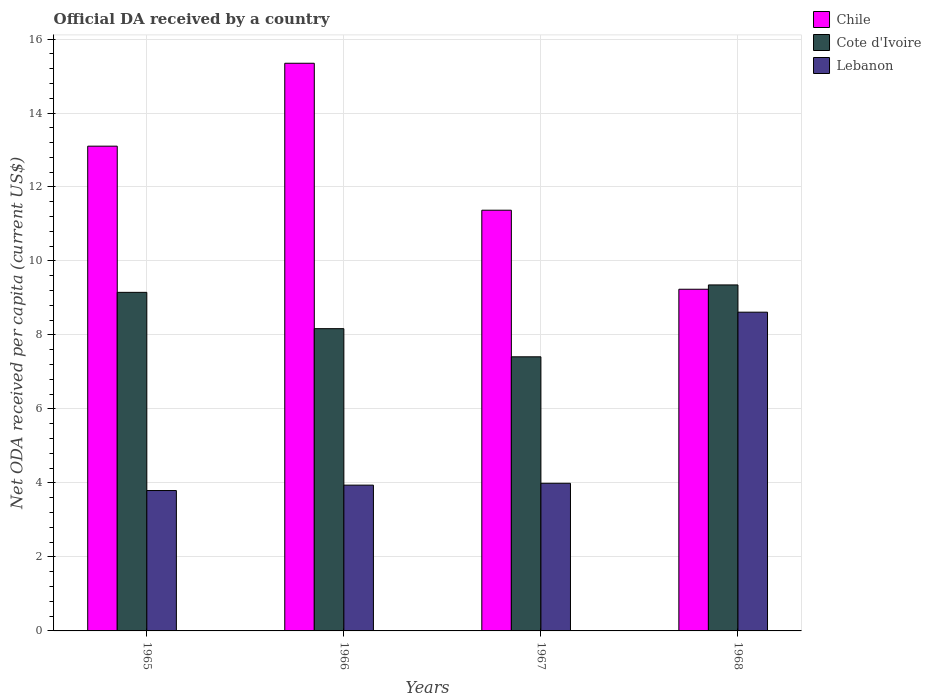How many groups of bars are there?
Your response must be concise. 4. Are the number of bars per tick equal to the number of legend labels?
Your answer should be compact. Yes. What is the label of the 4th group of bars from the left?
Keep it short and to the point. 1968. What is the ODA received in in Chile in 1965?
Ensure brevity in your answer.  13.1. Across all years, what is the maximum ODA received in in Chile?
Your answer should be very brief. 15.34. Across all years, what is the minimum ODA received in in Chile?
Make the answer very short. 9.24. In which year was the ODA received in in Chile maximum?
Your answer should be compact. 1966. In which year was the ODA received in in Lebanon minimum?
Provide a succinct answer. 1965. What is the total ODA received in in Cote d'Ivoire in the graph?
Provide a short and direct response. 34.08. What is the difference between the ODA received in in Chile in 1966 and that in 1967?
Provide a short and direct response. 3.97. What is the difference between the ODA received in in Lebanon in 1966 and the ODA received in in Cote d'Ivoire in 1967?
Your answer should be very brief. -3.47. What is the average ODA received in in Lebanon per year?
Your response must be concise. 5.09. In the year 1968, what is the difference between the ODA received in in Cote d'Ivoire and ODA received in in Chile?
Your response must be concise. 0.12. What is the ratio of the ODA received in in Lebanon in 1965 to that in 1968?
Provide a short and direct response. 0.44. Is the ODA received in in Lebanon in 1965 less than that in 1968?
Your response must be concise. Yes. What is the difference between the highest and the second highest ODA received in in Chile?
Your answer should be compact. 2.24. What is the difference between the highest and the lowest ODA received in in Lebanon?
Make the answer very short. 4.82. Is the sum of the ODA received in in Chile in 1966 and 1967 greater than the maximum ODA received in in Cote d'Ivoire across all years?
Give a very brief answer. Yes. What does the 3rd bar from the left in 1968 represents?
Your answer should be compact. Lebanon. Is it the case that in every year, the sum of the ODA received in in Cote d'Ivoire and ODA received in in Chile is greater than the ODA received in in Lebanon?
Make the answer very short. Yes. How many bars are there?
Your answer should be very brief. 12. Are all the bars in the graph horizontal?
Your response must be concise. No. What is the difference between two consecutive major ticks on the Y-axis?
Your answer should be compact. 2. Does the graph contain any zero values?
Provide a succinct answer. No. How are the legend labels stacked?
Ensure brevity in your answer.  Vertical. What is the title of the graph?
Your answer should be very brief. Official DA received by a country. Does "Philippines" appear as one of the legend labels in the graph?
Your answer should be compact. No. What is the label or title of the X-axis?
Your response must be concise. Years. What is the label or title of the Y-axis?
Offer a terse response. Net ODA received per capita (current US$). What is the Net ODA received per capita (current US$) in Chile in 1965?
Offer a very short reply. 13.1. What is the Net ODA received per capita (current US$) in Cote d'Ivoire in 1965?
Your answer should be compact. 9.15. What is the Net ODA received per capita (current US$) in Lebanon in 1965?
Your answer should be compact. 3.79. What is the Net ODA received per capita (current US$) of Chile in 1966?
Keep it short and to the point. 15.34. What is the Net ODA received per capita (current US$) in Cote d'Ivoire in 1966?
Your answer should be very brief. 8.17. What is the Net ODA received per capita (current US$) in Lebanon in 1966?
Make the answer very short. 3.94. What is the Net ODA received per capita (current US$) in Chile in 1967?
Provide a short and direct response. 11.37. What is the Net ODA received per capita (current US$) of Cote d'Ivoire in 1967?
Your response must be concise. 7.41. What is the Net ODA received per capita (current US$) of Lebanon in 1967?
Offer a very short reply. 3.99. What is the Net ODA received per capita (current US$) of Chile in 1968?
Your response must be concise. 9.24. What is the Net ODA received per capita (current US$) of Cote d'Ivoire in 1968?
Provide a short and direct response. 9.35. What is the Net ODA received per capita (current US$) in Lebanon in 1968?
Your answer should be very brief. 8.62. Across all years, what is the maximum Net ODA received per capita (current US$) of Chile?
Ensure brevity in your answer.  15.34. Across all years, what is the maximum Net ODA received per capita (current US$) in Cote d'Ivoire?
Your response must be concise. 9.35. Across all years, what is the maximum Net ODA received per capita (current US$) of Lebanon?
Your answer should be very brief. 8.62. Across all years, what is the minimum Net ODA received per capita (current US$) in Chile?
Provide a short and direct response. 9.24. Across all years, what is the minimum Net ODA received per capita (current US$) in Cote d'Ivoire?
Keep it short and to the point. 7.41. Across all years, what is the minimum Net ODA received per capita (current US$) in Lebanon?
Provide a short and direct response. 3.79. What is the total Net ODA received per capita (current US$) of Chile in the graph?
Make the answer very short. 49.06. What is the total Net ODA received per capita (current US$) in Cote d'Ivoire in the graph?
Keep it short and to the point. 34.08. What is the total Net ODA received per capita (current US$) in Lebanon in the graph?
Provide a short and direct response. 20.34. What is the difference between the Net ODA received per capita (current US$) in Chile in 1965 and that in 1966?
Offer a terse response. -2.24. What is the difference between the Net ODA received per capita (current US$) of Cote d'Ivoire in 1965 and that in 1966?
Offer a terse response. 0.98. What is the difference between the Net ODA received per capita (current US$) in Lebanon in 1965 and that in 1966?
Give a very brief answer. -0.15. What is the difference between the Net ODA received per capita (current US$) of Chile in 1965 and that in 1967?
Make the answer very short. 1.73. What is the difference between the Net ODA received per capita (current US$) of Cote d'Ivoire in 1965 and that in 1967?
Provide a short and direct response. 1.74. What is the difference between the Net ODA received per capita (current US$) in Lebanon in 1965 and that in 1967?
Make the answer very short. -0.2. What is the difference between the Net ODA received per capita (current US$) of Chile in 1965 and that in 1968?
Keep it short and to the point. 3.87. What is the difference between the Net ODA received per capita (current US$) in Cote d'Ivoire in 1965 and that in 1968?
Offer a very short reply. -0.2. What is the difference between the Net ODA received per capita (current US$) of Lebanon in 1965 and that in 1968?
Offer a very short reply. -4.82. What is the difference between the Net ODA received per capita (current US$) in Chile in 1966 and that in 1967?
Offer a terse response. 3.97. What is the difference between the Net ODA received per capita (current US$) of Cote d'Ivoire in 1966 and that in 1967?
Offer a very short reply. 0.76. What is the difference between the Net ODA received per capita (current US$) of Lebanon in 1966 and that in 1967?
Provide a short and direct response. -0.05. What is the difference between the Net ODA received per capita (current US$) of Chile in 1966 and that in 1968?
Provide a succinct answer. 6.11. What is the difference between the Net ODA received per capita (current US$) of Cote d'Ivoire in 1966 and that in 1968?
Your answer should be compact. -1.18. What is the difference between the Net ODA received per capita (current US$) in Lebanon in 1966 and that in 1968?
Ensure brevity in your answer.  -4.68. What is the difference between the Net ODA received per capita (current US$) in Chile in 1967 and that in 1968?
Ensure brevity in your answer.  2.14. What is the difference between the Net ODA received per capita (current US$) in Cote d'Ivoire in 1967 and that in 1968?
Keep it short and to the point. -1.94. What is the difference between the Net ODA received per capita (current US$) in Lebanon in 1967 and that in 1968?
Your response must be concise. -4.63. What is the difference between the Net ODA received per capita (current US$) in Chile in 1965 and the Net ODA received per capita (current US$) in Cote d'Ivoire in 1966?
Your answer should be very brief. 4.93. What is the difference between the Net ODA received per capita (current US$) in Chile in 1965 and the Net ODA received per capita (current US$) in Lebanon in 1966?
Offer a very short reply. 9.16. What is the difference between the Net ODA received per capita (current US$) of Cote d'Ivoire in 1965 and the Net ODA received per capita (current US$) of Lebanon in 1966?
Ensure brevity in your answer.  5.21. What is the difference between the Net ODA received per capita (current US$) in Chile in 1965 and the Net ODA received per capita (current US$) in Cote d'Ivoire in 1967?
Give a very brief answer. 5.69. What is the difference between the Net ODA received per capita (current US$) in Chile in 1965 and the Net ODA received per capita (current US$) in Lebanon in 1967?
Keep it short and to the point. 9.11. What is the difference between the Net ODA received per capita (current US$) of Cote d'Ivoire in 1965 and the Net ODA received per capita (current US$) of Lebanon in 1967?
Your answer should be very brief. 5.16. What is the difference between the Net ODA received per capita (current US$) in Chile in 1965 and the Net ODA received per capita (current US$) in Cote d'Ivoire in 1968?
Your answer should be very brief. 3.75. What is the difference between the Net ODA received per capita (current US$) in Chile in 1965 and the Net ODA received per capita (current US$) in Lebanon in 1968?
Make the answer very short. 4.49. What is the difference between the Net ODA received per capita (current US$) of Cote d'Ivoire in 1965 and the Net ODA received per capita (current US$) of Lebanon in 1968?
Ensure brevity in your answer.  0.54. What is the difference between the Net ODA received per capita (current US$) of Chile in 1966 and the Net ODA received per capita (current US$) of Cote d'Ivoire in 1967?
Provide a succinct answer. 7.94. What is the difference between the Net ODA received per capita (current US$) of Chile in 1966 and the Net ODA received per capita (current US$) of Lebanon in 1967?
Your response must be concise. 11.35. What is the difference between the Net ODA received per capita (current US$) in Cote d'Ivoire in 1966 and the Net ODA received per capita (current US$) in Lebanon in 1967?
Keep it short and to the point. 4.18. What is the difference between the Net ODA received per capita (current US$) in Chile in 1966 and the Net ODA received per capita (current US$) in Cote d'Ivoire in 1968?
Offer a terse response. 5.99. What is the difference between the Net ODA received per capita (current US$) of Chile in 1966 and the Net ODA received per capita (current US$) of Lebanon in 1968?
Provide a succinct answer. 6.73. What is the difference between the Net ODA received per capita (current US$) of Cote d'Ivoire in 1966 and the Net ODA received per capita (current US$) of Lebanon in 1968?
Your response must be concise. -0.45. What is the difference between the Net ODA received per capita (current US$) in Chile in 1967 and the Net ODA received per capita (current US$) in Cote d'Ivoire in 1968?
Offer a terse response. 2.02. What is the difference between the Net ODA received per capita (current US$) of Chile in 1967 and the Net ODA received per capita (current US$) of Lebanon in 1968?
Make the answer very short. 2.76. What is the difference between the Net ODA received per capita (current US$) in Cote d'Ivoire in 1967 and the Net ODA received per capita (current US$) in Lebanon in 1968?
Your answer should be compact. -1.21. What is the average Net ODA received per capita (current US$) in Chile per year?
Offer a very short reply. 12.26. What is the average Net ODA received per capita (current US$) in Cote d'Ivoire per year?
Offer a terse response. 8.52. What is the average Net ODA received per capita (current US$) of Lebanon per year?
Offer a very short reply. 5.09. In the year 1965, what is the difference between the Net ODA received per capita (current US$) in Chile and Net ODA received per capita (current US$) in Cote d'Ivoire?
Keep it short and to the point. 3.95. In the year 1965, what is the difference between the Net ODA received per capita (current US$) of Chile and Net ODA received per capita (current US$) of Lebanon?
Your response must be concise. 9.31. In the year 1965, what is the difference between the Net ODA received per capita (current US$) of Cote d'Ivoire and Net ODA received per capita (current US$) of Lebanon?
Keep it short and to the point. 5.36. In the year 1966, what is the difference between the Net ODA received per capita (current US$) of Chile and Net ODA received per capita (current US$) of Cote d'Ivoire?
Offer a terse response. 7.17. In the year 1966, what is the difference between the Net ODA received per capita (current US$) in Chile and Net ODA received per capita (current US$) in Lebanon?
Provide a short and direct response. 11.4. In the year 1966, what is the difference between the Net ODA received per capita (current US$) in Cote d'Ivoire and Net ODA received per capita (current US$) in Lebanon?
Your answer should be very brief. 4.23. In the year 1967, what is the difference between the Net ODA received per capita (current US$) in Chile and Net ODA received per capita (current US$) in Cote d'Ivoire?
Offer a very short reply. 3.96. In the year 1967, what is the difference between the Net ODA received per capita (current US$) in Chile and Net ODA received per capita (current US$) in Lebanon?
Offer a very short reply. 7.38. In the year 1967, what is the difference between the Net ODA received per capita (current US$) in Cote d'Ivoire and Net ODA received per capita (current US$) in Lebanon?
Keep it short and to the point. 3.42. In the year 1968, what is the difference between the Net ODA received per capita (current US$) in Chile and Net ODA received per capita (current US$) in Cote d'Ivoire?
Your answer should be very brief. -0.12. In the year 1968, what is the difference between the Net ODA received per capita (current US$) in Chile and Net ODA received per capita (current US$) in Lebanon?
Your answer should be compact. 0.62. In the year 1968, what is the difference between the Net ODA received per capita (current US$) of Cote d'Ivoire and Net ODA received per capita (current US$) of Lebanon?
Your answer should be compact. 0.74. What is the ratio of the Net ODA received per capita (current US$) of Chile in 1965 to that in 1966?
Ensure brevity in your answer.  0.85. What is the ratio of the Net ODA received per capita (current US$) of Cote d'Ivoire in 1965 to that in 1966?
Your answer should be very brief. 1.12. What is the ratio of the Net ODA received per capita (current US$) of Lebanon in 1965 to that in 1966?
Give a very brief answer. 0.96. What is the ratio of the Net ODA received per capita (current US$) of Chile in 1965 to that in 1967?
Offer a very short reply. 1.15. What is the ratio of the Net ODA received per capita (current US$) in Cote d'Ivoire in 1965 to that in 1967?
Your answer should be very brief. 1.24. What is the ratio of the Net ODA received per capita (current US$) of Lebanon in 1965 to that in 1967?
Provide a short and direct response. 0.95. What is the ratio of the Net ODA received per capita (current US$) of Chile in 1965 to that in 1968?
Make the answer very short. 1.42. What is the ratio of the Net ODA received per capita (current US$) in Cote d'Ivoire in 1965 to that in 1968?
Provide a succinct answer. 0.98. What is the ratio of the Net ODA received per capita (current US$) of Lebanon in 1965 to that in 1968?
Offer a very short reply. 0.44. What is the ratio of the Net ODA received per capita (current US$) of Chile in 1966 to that in 1967?
Your response must be concise. 1.35. What is the ratio of the Net ODA received per capita (current US$) of Cote d'Ivoire in 1966 to that in 1967?
Keep it short and to the point. 1.1. What is the ratio of the Net ODA received per capita (current US$) of Lebanon in 1966 to that in 1967?
Make the answer very short. 0.99. What is the ratio of the Net ODA received per capita (current US$) in Chile in 1966 to that in 1968?
Your response must be concise. 1.66. What is the ratio of the Net ODA received per capita (current US$) of Cote d'Ivoire in 1966 to that in 1968?
Make the answer very short. 0.87. What is the ratio of the Net ODA received per capita (current US$) in Lebanon in 1966 to that in 1968?
Provide a short and direct response. 0.46. What is the ratio of the Net ODA received per capita (current US$) in Chile in 1967 to that in 1968?
Keep it short and to the point. 1.23. What is the ratio of the Net ODA received per capita (current US$) in Cote d'Ivoire in 1967 to that in 1968?
Make the answer very short. 0.79. What is the ratio of the Net ODA received per capita (current US$) of Lebanon in 1967 to that in 1968?
Give a very brief answer. 0.46. What is the difference between the highest and the second highest Net ODA received per capita (current US$) of Chile?
Make the answer very short. 2.24. What is the difference between the highest and the second highest Net ODA received per capita (current US$) in Cote d'Ivoire?
Provide a succinct answer. 0.2. What is the difference between the highest and the second highest Net ODA received per capita (current US$) of Lebanon?
Offer a terse response. 4.63. What is the difference between the highest and the lowest Net ODA received per capita (current US$) in Chile?
Your answer should be compact. 6.11. What is the difference between the highest and the lowest Net ODA received per capita (current US$) in Cote d'Ivoire?
Make the answer very short. 1.94. What is the difference between the highest and the lowest Net ODA received per capita (current US$) in Lebanon?
Give a very brief answer. 4.82. 